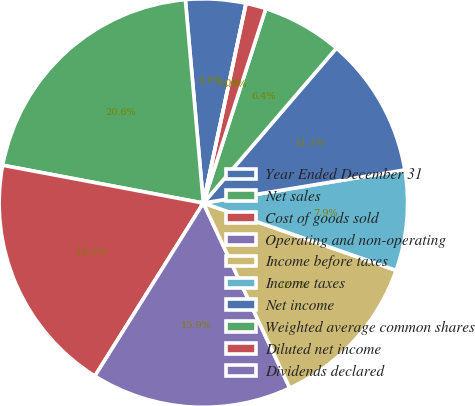Convert chart to OTSL. <chart><loc_0><loc_0><loc_500><loc_500><pie_chart><fcel>Year Ended December 31<fcel>Net sales<fcel>Cost of goods sold<fcel>Operating and non-operating<fcel>Income before taxes<fcel>Income taxes<fcel>Net income<fcel>Weighted average common shares<fcel>Diluted net income<fcel>Dividends declared<nl><fcel>4.76%<fcel>20.63%<fcel>19.05%<fcel>15.87%<fcel>12.7%<fcel>7.94%<fcel>11.11%<fcel>6.35%<fcel>1.59%<fcel>0.0%<nl></chart> 